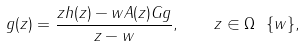Convert formula to latex. <formula><loc_0><loc_0><loc_500><loc_500>g ( z ) = \frac { z h ( z ) - w A ( z ) G g } { z - w } , \quad z \in \Omega \ \{ w \} ,</formula> 